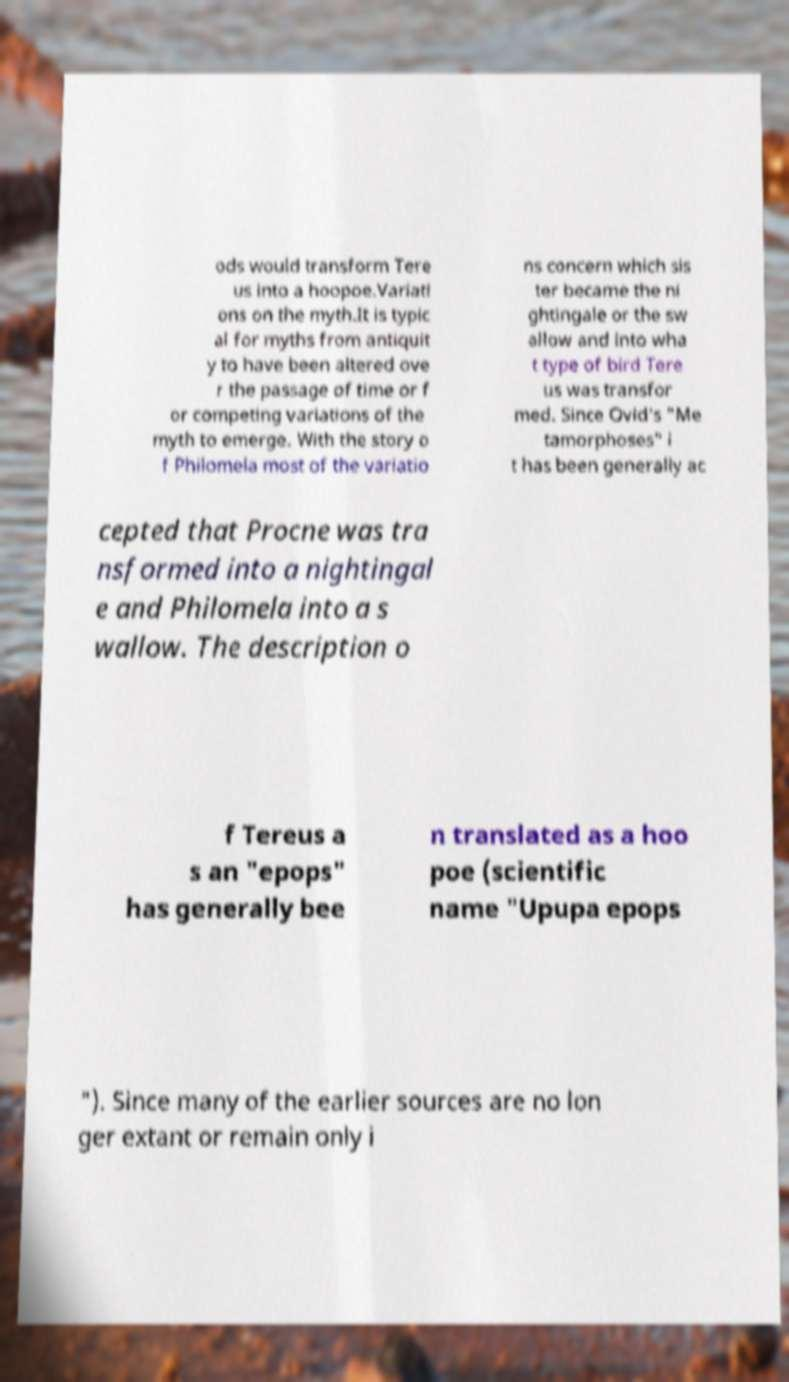There's text embedded in this image that I need extracted. Can you transcribe it verbatim? ods would transform Tere us into a hoopoe.Variati ons on the myth.It is typic al for myths from antiquit y to have been altered ove r the passage of time or f or competing variations of the myth to emerge. With the story o f Philomela most of the variatio ns concern which sis ter became the ni ghtingale or the sw allow and into wha t type of bird Tere us was transfor med. Since Ovid's "Me tamorphoses" i t has been generally ac cepted that Procne was tra nsformed into a nightingal e and Philomela into a s wallow. The description o f Tereus a s an "epops" has generally bee n translated as a hoo poe (scientific name "Upupa epops "). Since many of the earlier sources are no lon ger extant or remain only i 